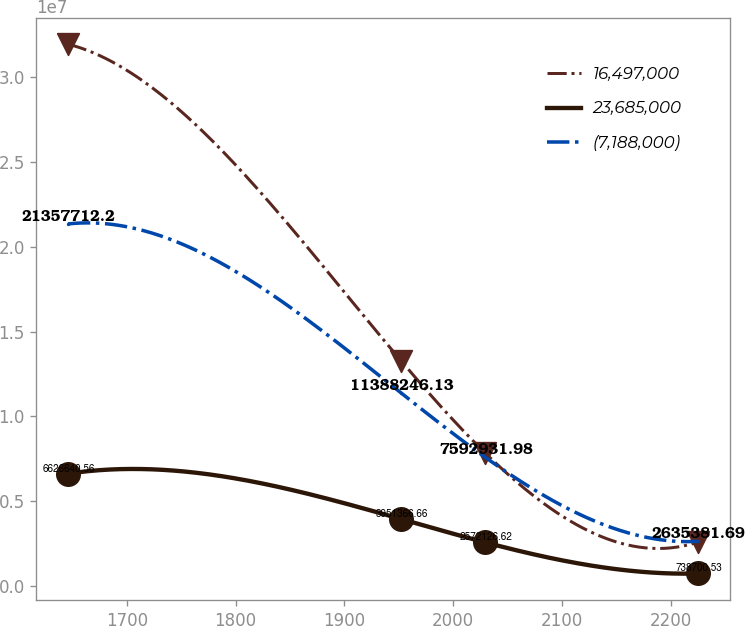<chart> <loc_0><loc_0><loc_500><loc_500><line_chart><ecel><fcel>16,497,000<fcel>23,685,000<fcel>(7,188,000)<nl><fcel>1645.74<fcel>3.19635e+07<fcel>6.62664e+06<fcel>2.13577e+07<nl><fcel>1952.09<fcel>1.32853e+07<fcel>3.95137e+06<fcel>1.13882e+07<nl><fcel>2029.46<fcel>7.84435e+06<fcel>2.57213e+06<fcel>7.59293e+06<nl><fcel>2225.13<fcel>2.59472e+06<fcel>738701<fcel>2.63538e+06<nl></chart> 